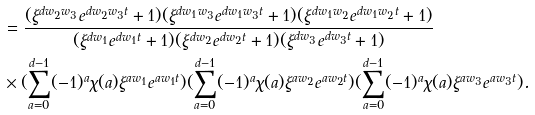Convert formula to latex. <formula><loc_0><loc_0><loc_500><loc_500>& = \frac { ( \xi ^ { d w _ { 2 } w _ { 3 } } e ^ { d w _ { 2 } w _ { 3 } t } + 1 ) ( \xi ^ { d w _ { 1 } w _ { 3 } } e ^ { d w _ { 1 } w _ { 3 } t } + 1 ) ( \xi ^ { d w _ { 1 } w _ { 2 } } e ^ { d w _ { 1 } w _ { 2 } t } + 1 ) } { ( \xi ^ { d w _ { 1 } } e ^ { d w _ { 1 } t } + 1 ) ( \xi ^ { d w _ { 2 } } e ^ { d w _ { 2 } t } + 1 ) ( \xi ^ { d w _ { 3 } } e ^ { d w _ { 3 } t } + 1 ) } \\ & \times ( \sum _ { a = 0 } ^ { d - 1 } ( - 1 ) ^ { a } \chi ( a ) \xi ^ { a w _ { 1 } } e ^ { a w _ { 1 } t } ) ( \sum _ { a = 0 } ^ { d - 1 } ( - 1 ) ^ { a } \chi ( a ) \xi ^ { a w _ { 2 } } e ^ { a w _ { 2 } t } ) ( \sum _ { a = 0 } ^ { d - 1 } ( - 1 ) ^ { a } \chi ( a ) \xi ^ { a w _ { 3 } } e ^ { a w _ { 3 } t } ) .</formula> 